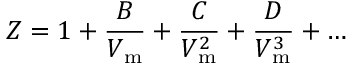<formula> <loc_0><loc_0><loc_500><loc_500>Z = 1 + { \frac { B } { V _ { m } } } + { \frac { C } { V _ { m } ^ { 2 } } } + { \frac { D } { V _ { m } ^ { 3 } } } + \dots</formula> 